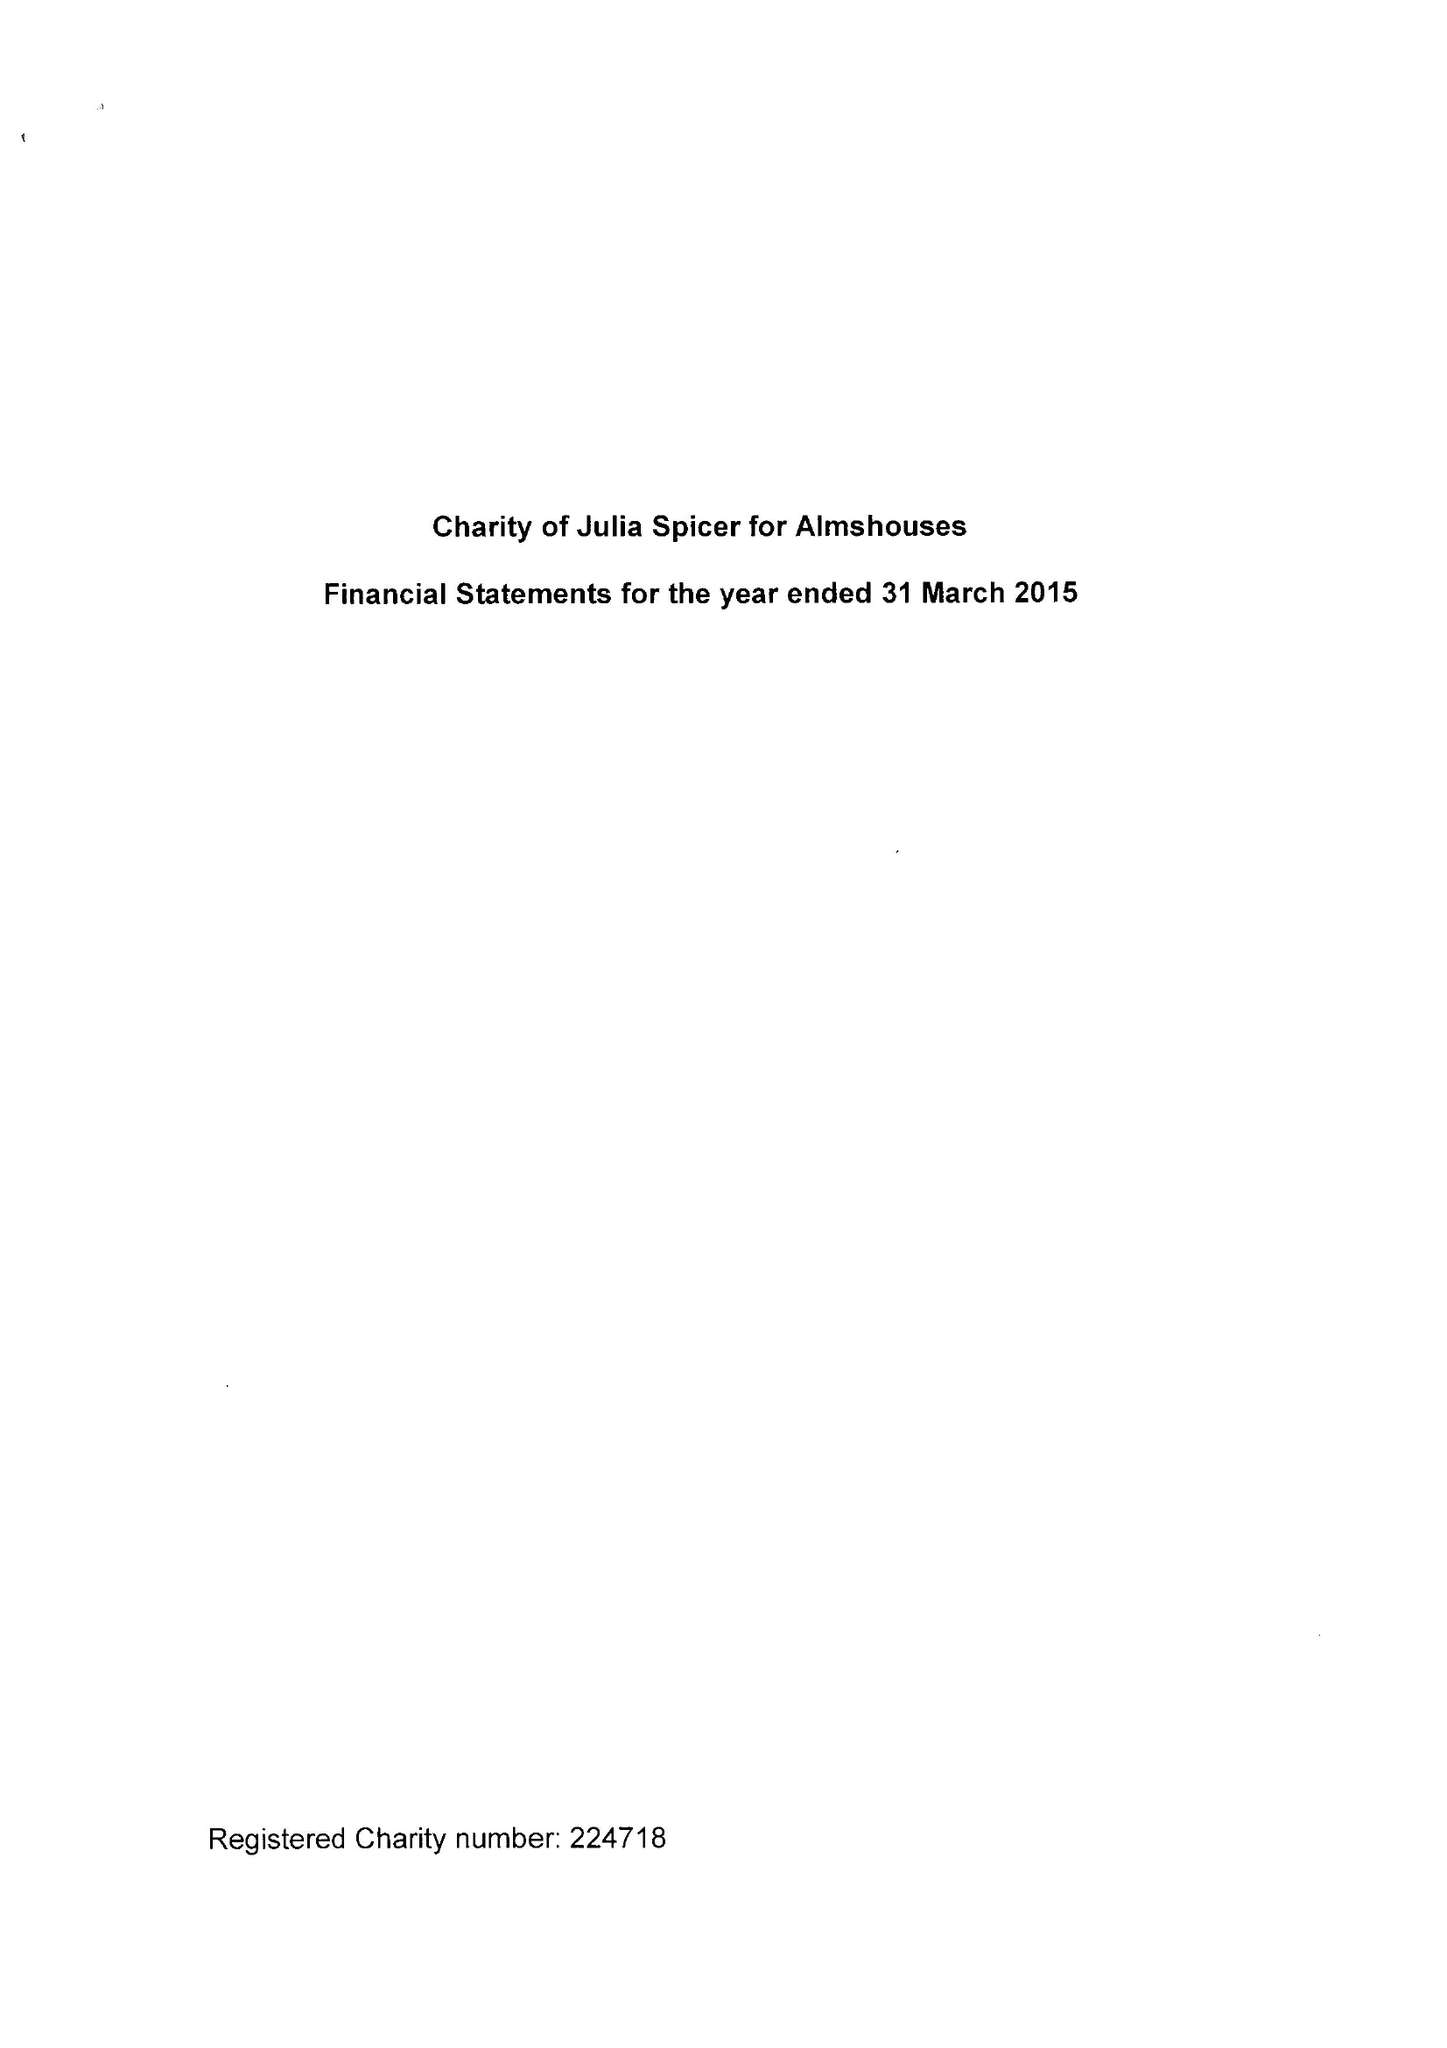What is the value for the report_date?
Answer the question using a single word or phrase. 2015-03-31 